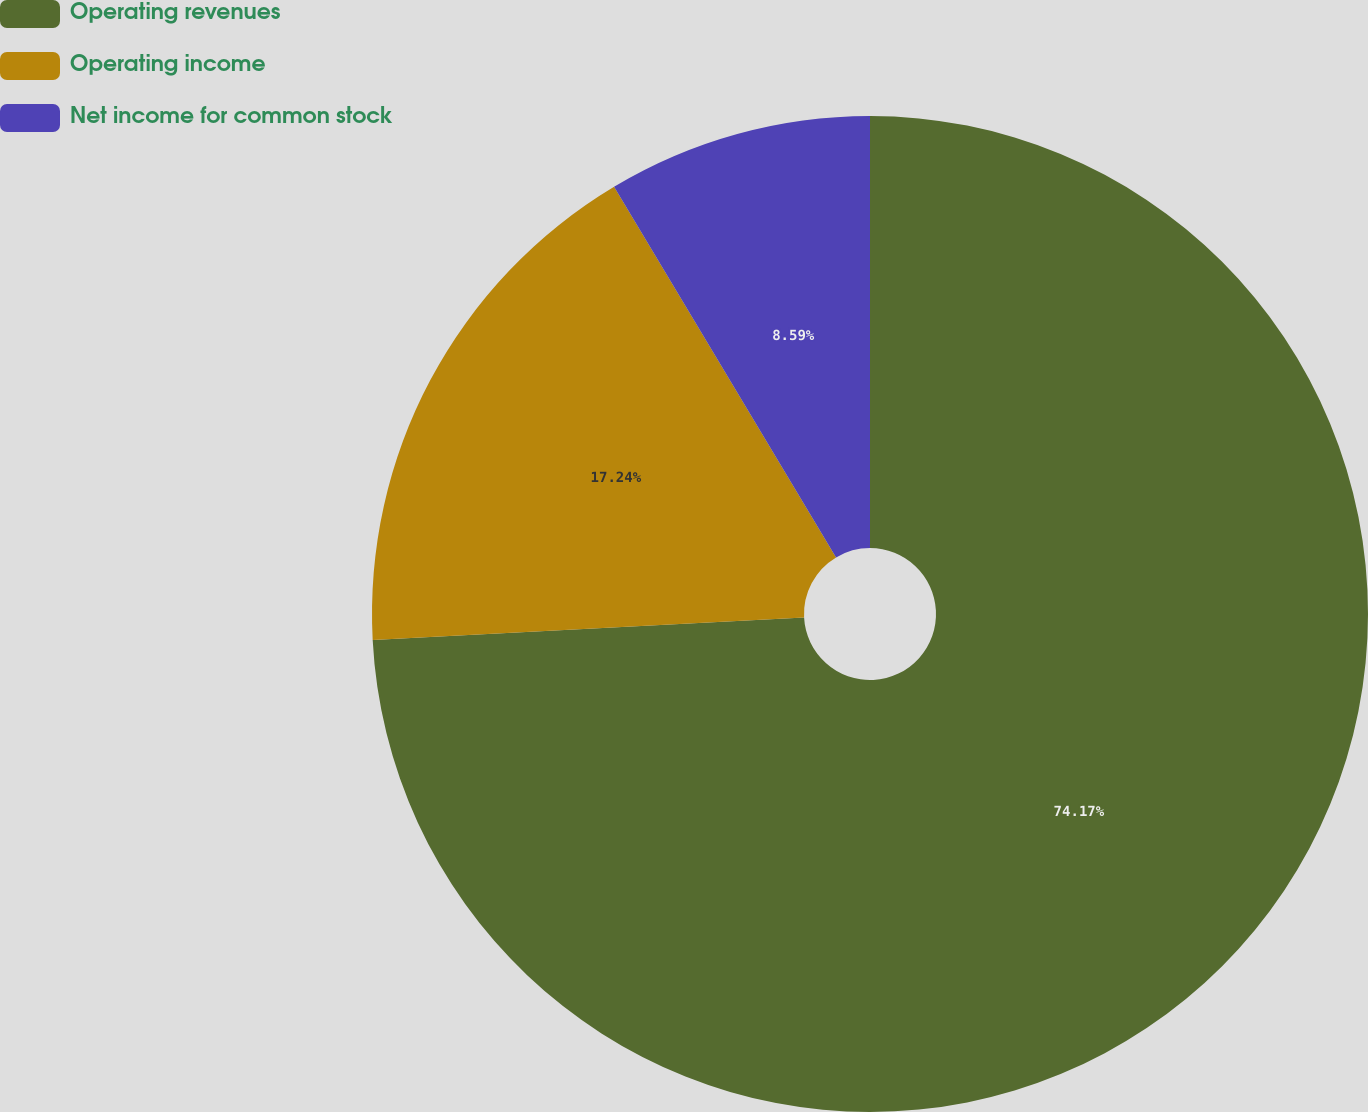Convert chart. <chart><loc_0><loc_0><loc_500><loc_500><pie_chart><fcel>Operating revenues<fcel>Operating income<fcel>Net income for common stock<nl><fcel>74.17%<fcel>17.24%<fcel>8.59%<nl></chart> 